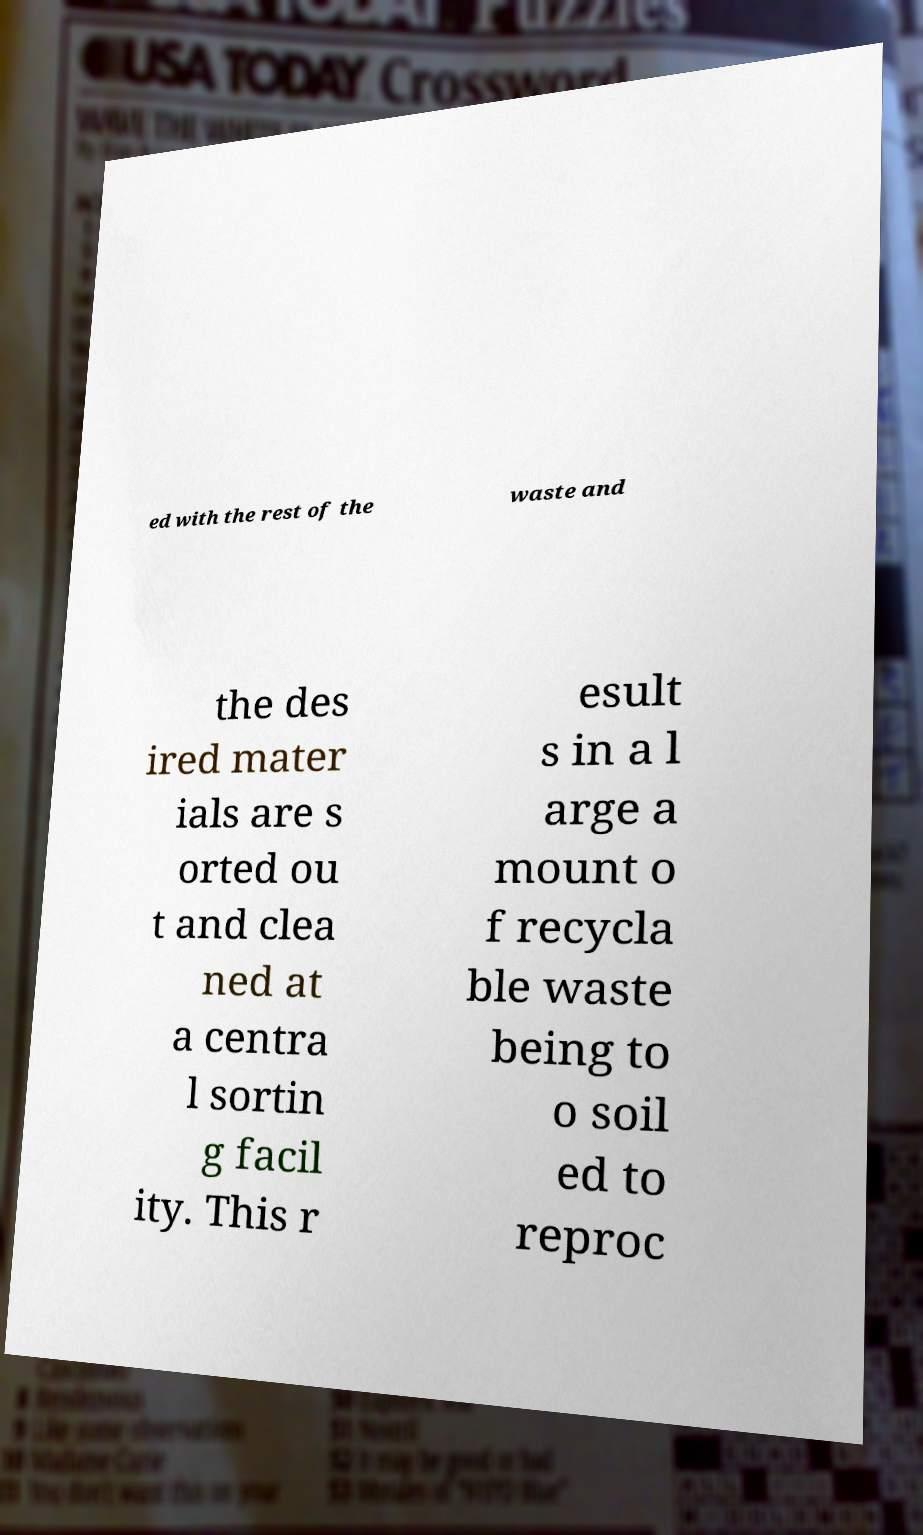Could you assist in decoding the text presented in this image and type it out clearly? ed with the rest of the waste and the des ired mater ials are s orted ou t and clea ned at a centra l sortin g facil ity. This r esult s in a l arge a mount o f recycla ble waste being to o soil ed to reproc 